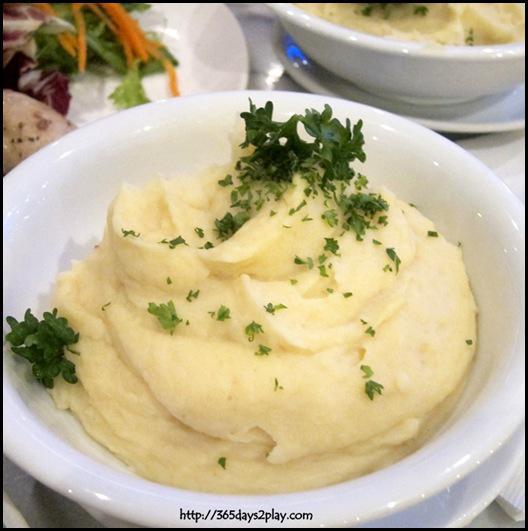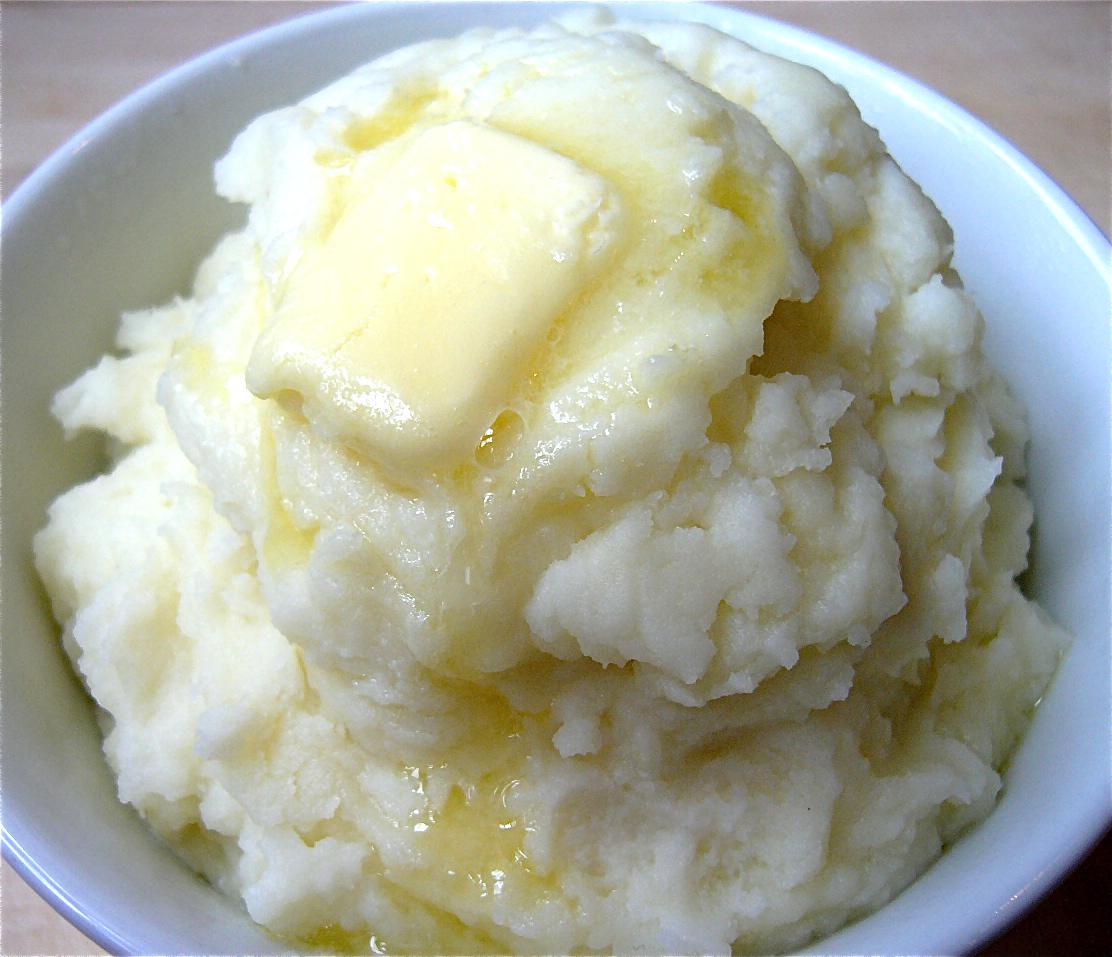The first image is the image on the left, the second image is the image on the right. Considering the images on both sides, is "One serving of mashed potatoes is garnished with a pat of butter." valid? Answer yes or no. Yes. 